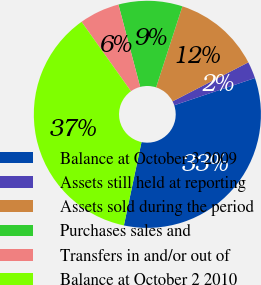<chart> <loc_0><loc_0><loc_500><loc_500><pie_chart><fcel>Balance at October 3 2009<fcel>Assets still held at reporting<fcel>Assets sold during the period<fcel>Purchases sales and<fcel>Transfers in and/or out of<fcel>Balance at October 2 2010<nl><fcel>33.49%<fcel>2.39%<fcel>12.44%<fcel>9.09%<fcel>5.74%<fcel>36.84%<nl></chart> 